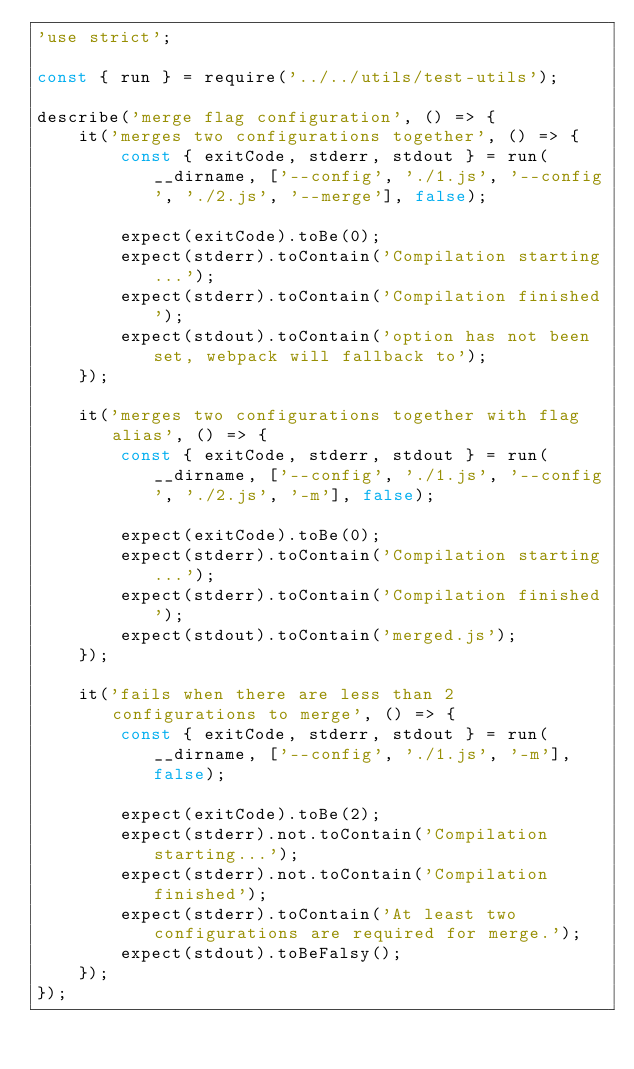<code> <loc_0><loc_0><loc_500><loc_500><_JavaScript_>'use strict';

const { run } = require('../../utils/test-utils');

describe('merge flag configuration', () => {
    it('merges two configurations together', () => {
        const { exitCode, stderr, stdout } = run(__dirname, ['--config', './1.js', '--config', './2.js', '--merge'], false);

        expect(exitCode).toBe(0);
        expect(stderr).toContain('Compilation starting...');
        expect(stderr).toContain('Compilation finished');
        expect(stdout).toContain('option has not been set, webpack will fallback to');
    });

    it('merges two configurations together with flag alias', () => {
        const { exitCode, stderr, stdout } = run(__dirname, ['--config', './1.js', '--config', './2.js', '-m'], false);

        expect(exitCode).toBe(0);
        expect(stderr).toContain('Compilation starting...');
        expect(stderr).toContain('Compilation finished');
        expect(stdout).toContain('merged.js');
    });

    it('fails when there are less than 2 configurations to merge', () => {
        const { exitCode, stderr, stdout } = run(__dirname, ['--config', './1.js', '-m'], false);

        expect(exitCode).toBe(2);
        expect(stderr).not.toContain('Compilation starting...');
        expect(stderr).not.toContain('Compilation finished');
        expect(stderr).toContain('At least two configurations are required for merge.');
        expect(stdout).toBeFalsy();
    });
});
</code> 